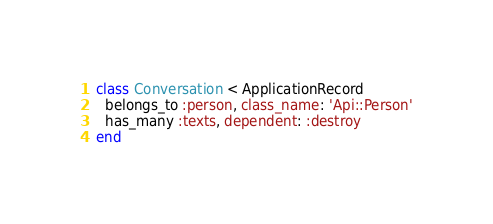<code> <loc_0><loc_0><loc_500><loc_500><_Ruby_>class Conversation < ApplicationRecord
  belongs_to :person, class_name: 'Api::Person'
  has_many :texts, dependent: :destroy
end
</code> 